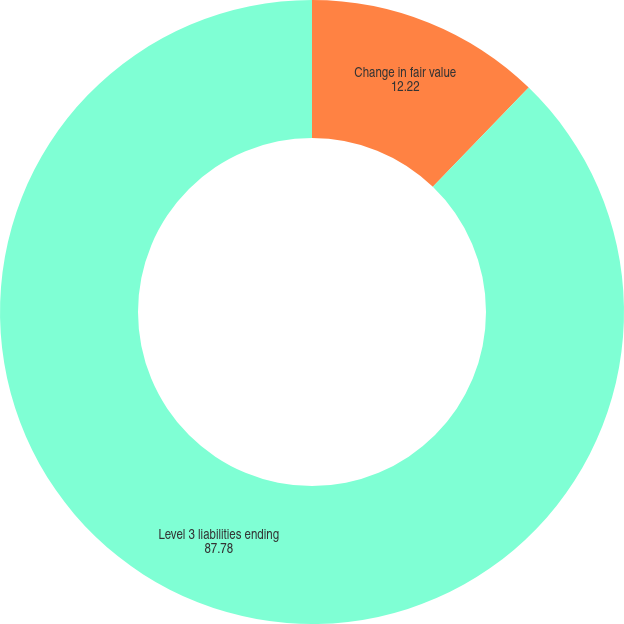Convert chart. <chart><loc_0><loc_0><loc_500><loc_500><pie_chart><fcel>Change in fair value<fcel>Level 3 liabilities ending<nl><fcel>12.22%<fcel>87.78%<nl></chart> 